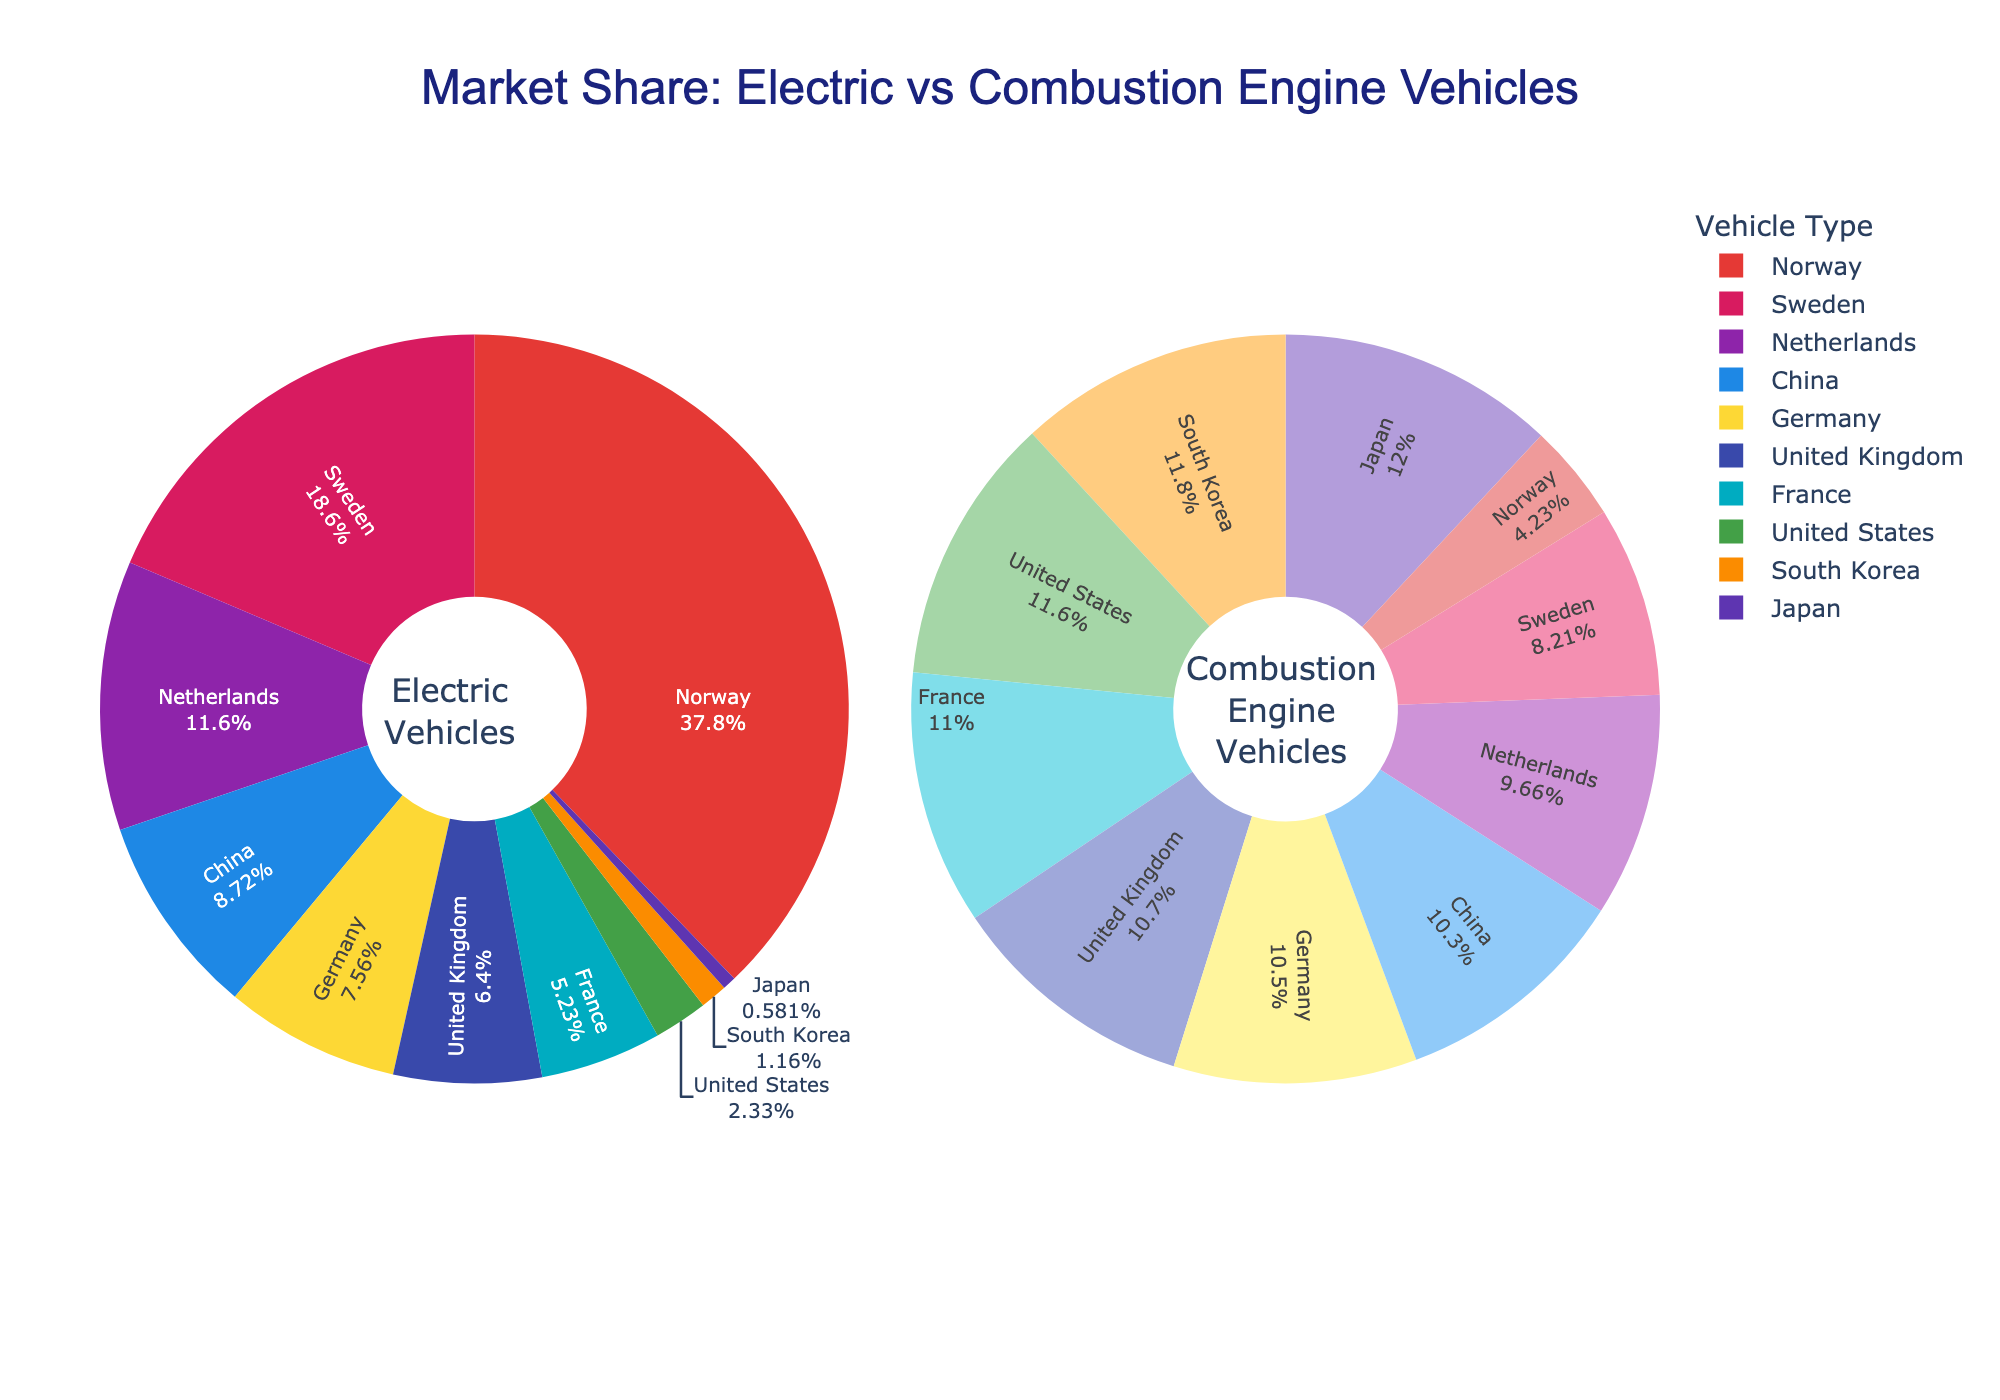What country has the highest market share of electric vehicles? Looking at the pie chart for Electric Vehicles, Norway has the largest proportion of its market represented by electric vehicles at 65%.
Answer: Norway Which market has a higher share of combustion engine vehicles, the United States or Sweden? Referring to the pie chart for Combustion Engine Vehicles, the United States has a higher share with 96% compared to Sweden's 68%.
Answer: United States What is the combined market share percentage of electric vehicles in Germany and France? The electric vehicle shares are 13% for Germany and 9% for France. Summing these percentages, 13 + 9 = 22%.
Answer: 22% How does Japan's market for electric vehicles compare to South Korea's? Japan's market share for electric vehicles is 1%, while South Korea's is 2%. Thus, South Korea has a higher market share of electric vehicles.
Answer: South Korea What is the difference in market share of combustion engine vehicles between China and the Netherlands? The shares of combustion engine vehicles are 85% for China and 80% for the Netherlands. The difference is calculated as 85 - 80 = 5%.
Answer: 5% Which market has a closer share of electric vehicles to the United Kingdom, France or the Netherlands? The United Kingdom has 11% of electric vehicles. France has 9% and the Netherlands has 20%. The closest share to 11% is France's 9%.
Answer: France What's the average market share of electric vehicles across the United States, Japan, and South Korea? The market shares are 4% for the United States, 1% for Japan, and 2% for South Korea. Adding and then dividing by 3: (4 + 1 + 2) / 3 = 7 / 3 ≈ 2.33%.
Answer: 2.33% Which market has a larger market share difference between electric and combustion engine vehicles, Norway or China? For Norway, the difference is 65% (EV) and 35% (CE), which is 65 - 35 = 30%. For China, it's 15% (EV) and 85% (CE), which is 85 - 15 = 70%. Therefore, China has a larger difference.
Answer: China In how many markets do electric vehicles make up less than 10% of market share? The markets where electric vehicles make up less than 10% are the United States (4%), Japan (1%), and South Korea (2%). There are three such markets.
Answer: 3 